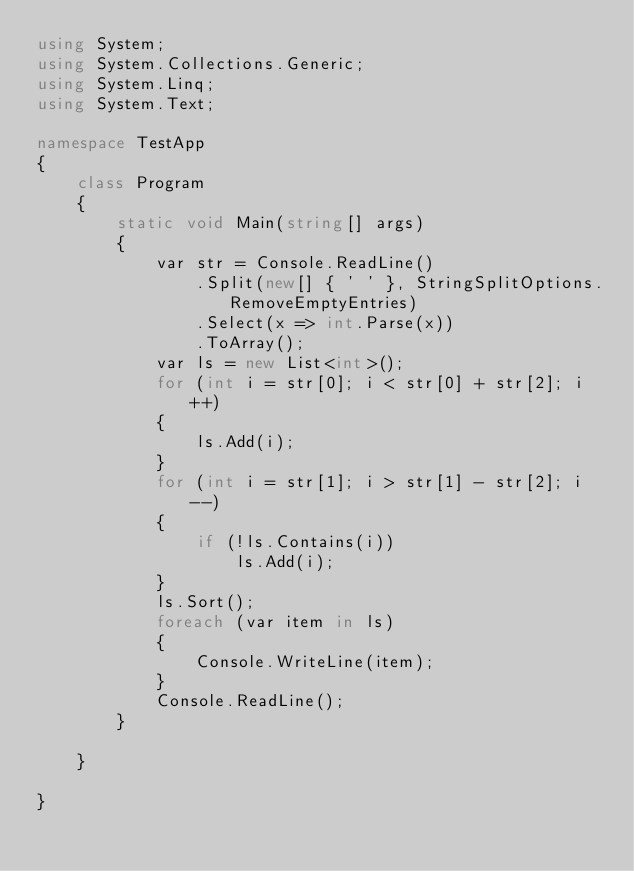<code> <loc_0><loc_0><loc_500><loc_500><_C#_>using System;
using System.Collections.Generic;
using System.Linq;
using System.Text;

namespace TestApp
{
    class Program
    {
        static void Main(string[] args)
        {
            var str = Console.ReadLine()
                .Split(new[] { ' ' }, StringSplitOptions.RemoveEmptyEntries)
                .Select(x => int.Parse(x))
                .ToArray();
            var ls = new List<int>();
            for (int i = str[0]; i < str[0] + str[2]; i++)
            {
                ls.Add(i);
            }
            for (int i = str[1]; i > str[1] - str[2]; i--)
            {
                if (!ls.Contains(i))
                    ls.Add(i);
            }
            ls.Sort();
            foreach (var item in ls)
            {
                Console.WriteLine(item);
            }
            Console.ReadLine();
        }
        
    }

}</code> 